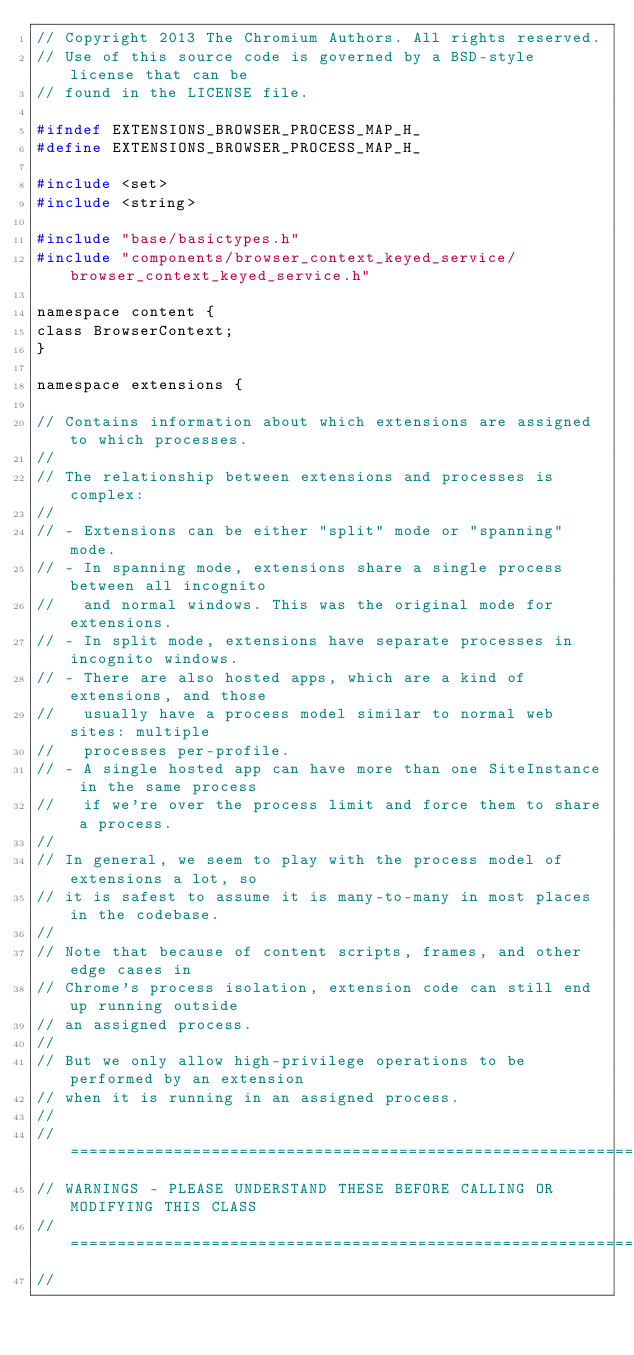<code> <loc_0><loc_0><loc_500><loc_500><_C_>// Copyright 2013 The Chromium Authors. All rights reserved.
// Use of this source code is governed by a BSD-style license that can be
// found in the LICENSE file.

#ifndef EXTENSIONS_BROWSER_PROCESS_MAP_H_
#define EXTENSIONS_BROWSER_PROCESS_MAP_H_

#include <set>
#include <string>

#include "base/basictypes.h"
#include "components/browser_context_keyed_service/browser_context_keyed_service.h"

namespace content {
class BrowserContext;
}

namespace extensions {

// Contains information about which extensions are assigned to which processes.
//
// The relationship between extensions and processes is complex:
//
// - Extensions can be either "split" mode or "spanning" mode.
// - In spanning mode, extensions share a single process between all incognito
//   and normal windows. This was the original mode for extensions.
// - In split mode, extensions have separate processes in incognito windows.
// - There are also hosted apps, which are a kind of extensions, and those
//   usually have a process model similar to normal web sites: multiple
//   processes per-profile.
// - A single hosted app can have more than one SiteInstance in the same process
//   if we're over the process limit and force them to share a process.
//
// In general, we seem to play with the process model of extensions a lot, so
// it is safest to assume it is many-to-many in most places in the codebase.
//
// Note that because of content scripts, frames, and other edge cases in
// Chrome's process isolation, extension code can still end up running outside
// an assigned process.
//
// But we only allow high-privilege operations to be performed by an extension
// when it is running in an assigned process.
//
// ===========================================================================
// WARNINGS - PLEASE UNDERSTAND THESE BEFORE CALLING OR MODIFYING THIS CLASS
// ===========================================================================
//</code> 